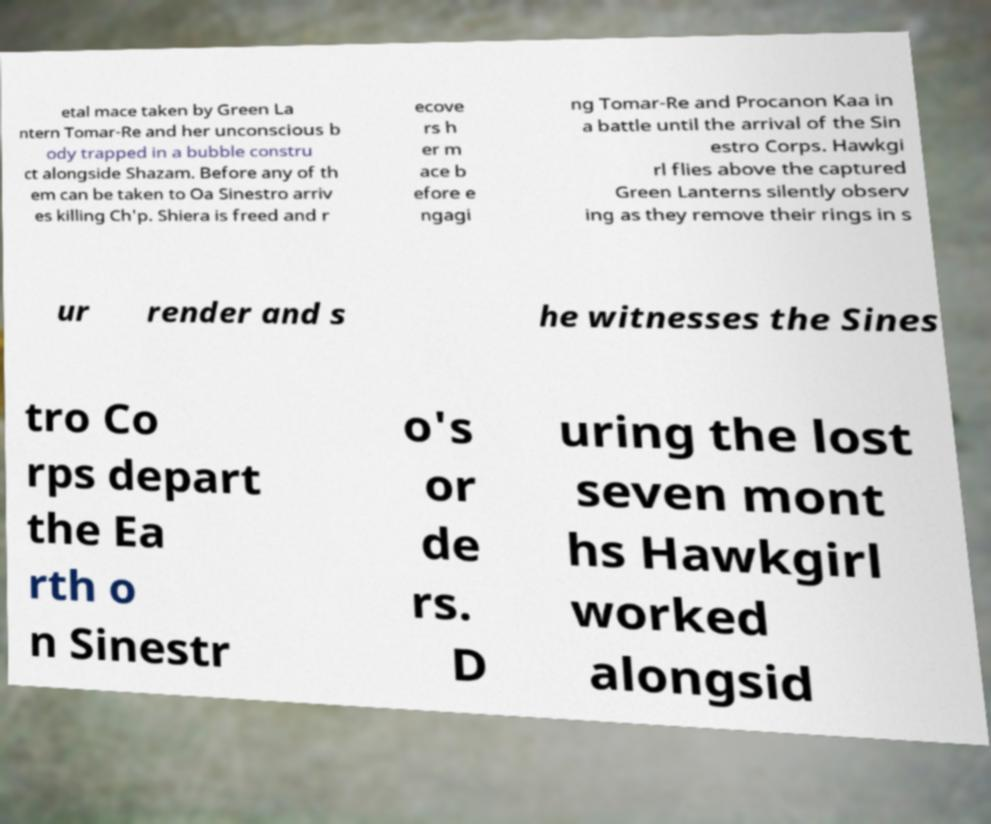There's text embedded in this image that I need extracted. Can you transcribe it verbatim? etal mace taken by Green La ntern Tomar-Re and her unconscious b ody trapped in a bubble constru ct alongside Shazam. Before any of th em can be taken to Oa Sinestro arriv es killing Ch'p. Shiera is freed and r ecove rs h er m ace b efore e ngagi ng Tomar-Re and Procanon Kaa in a battle until the arrival of the Sin estro Corps. Hawkgi rl flies above the captured Green Lanterns silently observ ing as they remove their rings in s ur render and s he witnesses the Sines tro Co rps depart the Ea rth o n Sinestr o's or de rs. D uring the lost seven mont hs Hawkgirl worked alongsid 